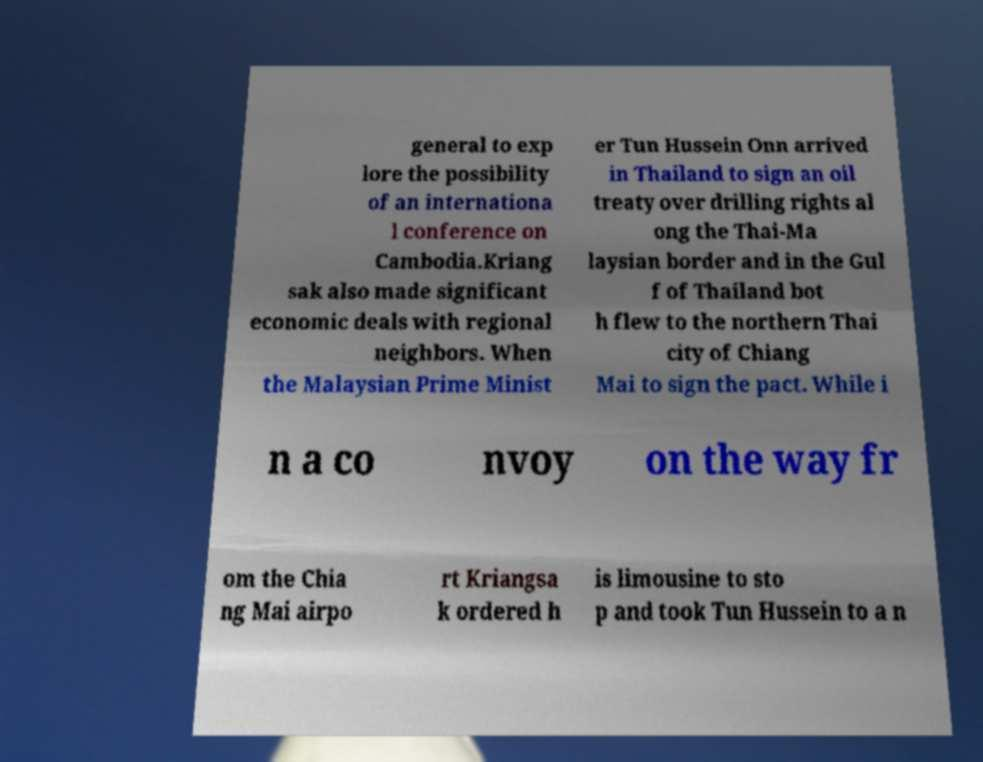What messages or text are displayed in this image? I need them in a readable, typed format. general to exp lore the possibility of an internationa l conference on Cambodia.Kriang sak also made significant economic deals with regional neighbors. When the Malaysian Prime Minist er Tun Hussein Onn arrived in Thailand to sign an oil treaty over drilling rights al ong the Thai-Ma laysian border and in the Gul f of Thailand bot h flew to the northern Thai city of Chiang Mai to sign the pact. While i n a co nvoy on the way fr om the Chia ng Mai airpo rt Kriangsa k ordered h is limousine to sto p and took Tun Hussein to a n 